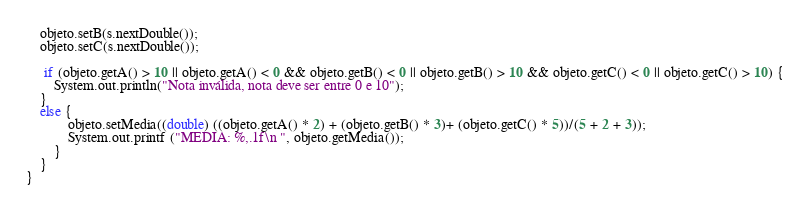Convert code to text. <code><loc_0><loc_0><loc_500><loc_500><_Java_>    objeto.setB(s.nextDouble());
    objeto.setC(s.nextDouble());
    
     if (objeto.getA() > 10 || objeto.getA() < 0 && objeto.getB() < 0 || objeto.getB() > 10 && objeto.getC() < 0 || objeto.getC() > 10) {
        System.out.println("Nota inválida, nota deve ser entre 0 e 10");
    } 
    else {
            objeto.setMedia((double) ((objeto.getA() * 2) + (objeto.getB() * 3)+ (objeto.getC() * 5))/(5 + 2 + 3));
            System.out.printf ("MEDIA: %,.1f\n ", objeto.getMedia());
        }
    }
}
</code> 